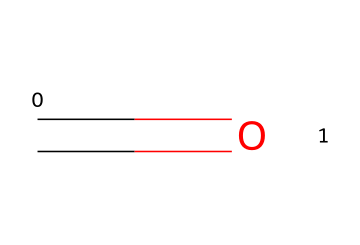What is the name of this chemical? The chemical structure shown, C=O, represents formaldehyde, which is a simple aldehyde.
Answer: formaldehyde How many hydrogen atoms are present in formaldehyde? The structure shows one carbon atom, one oxygen atom, and it typically has two hydrogens bonded to the carbon, thus there are two hydrogen atoms.
Answer: two What type of functional group characterizes aldehydes? The presence of the carbonyl group (C=O) indicates that this structure contains a carbonyl functional group, which is characteristic of aldehydes.
Answer: carbonyl What is the oxidation state of carbon in formaldehyde? In formaldehyde, the carbon atom is double-bonded to oxygen and single-bonded to two hydrogen atoms. Based on the bonds, the oxidation state of the carbon can be determined to be +1.
Answer: +1 Is formaldehyde a solid, liquid, or gas at room temperature? Formaldehyde is typically encountered as a gas at room temperature; however, it is often used in aqueous solution.
Answer: gas What is the primary use of formaldehyde in tragic theater? In tragic theater, formaldehyde is primarily used as a preservative for props, especially those meant to resemble biological tissues.
Answer: preservative 